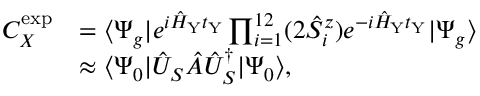Convert formula to latex. <formula><loc_0><loc_0><loc_500><loc_500>\begin{array} { r l } { C _ { X } ^ { e x p } } & { = \langle \Psi _ { g } | e ^ { i \hat { H } _ { Y } t _ { Y } } \prod _ { i = 1 } ^ { 1 2 } ( 2 \hat { S } _ { i } ^ { z } ) e ^ { - i \hat { H } _ { Y } t _ { Y } } | \Psi _ { g } \rangle } \\ & { \approx \langle \Psi _ { 0 } | \hat { U } _ { S } \hat { A } \hat { U } _ { S } ^ { \dagger } | \Psi _ { 0 } \rangle , } \end{array}</formula> 